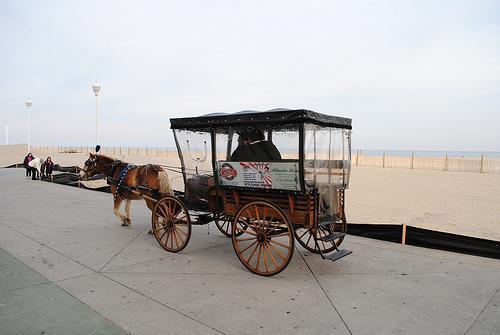How many horses are there?
Give a very brief answer. 1. How many wheels does the buggy have?
Give a very brief answer. 4. How many lamp posts are there?
Give a very brief answer. 2. 